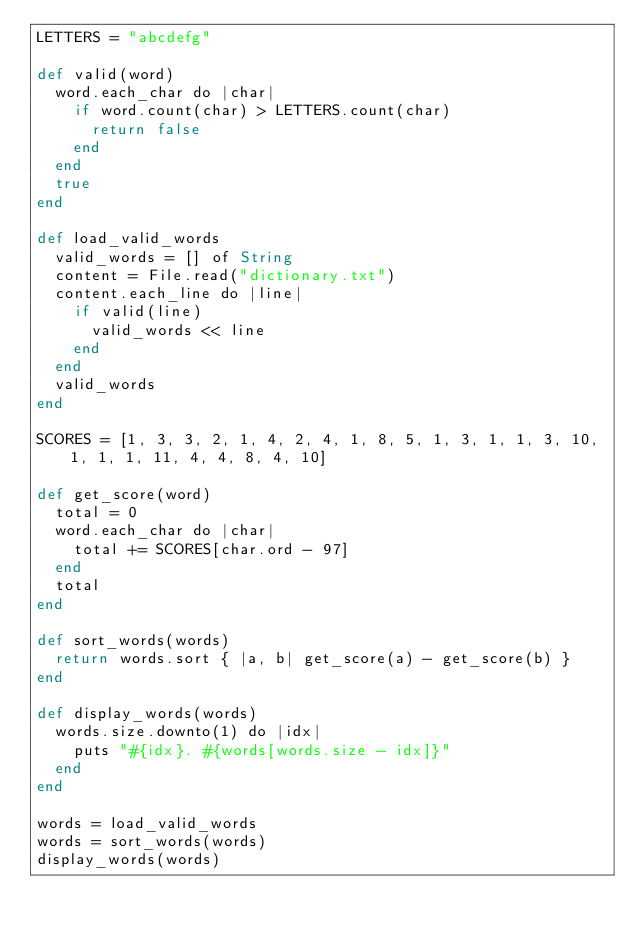<code> <loc_0><loc_0><loc_500><loc_500><_Crystal_>LETTERS = "abcdefg"

def valid(word)
  word.each_char do |char|
    if word.count(char) > LETTERS.count(char)
      return false
    end
  end
  true
end

def load_valid_words
  valid_words = [] of String
  content = File.read("dictionary.txt")
  content.each_line do |line|
    if valid(line)
      valid_words << line
    end
  end
  valid_words
end

SCORES = [1, 3, 3, 2, 1, 4, 2, 4, 1, 8, 5, 1, 3, 1, 1, 3, 10, 1, 1, 1, 11, 4, 4, 8, 4, 10]

def get_score(word)
  total = 0
  word.each_char do |char|
    total += SCORES[char.ord - 97]
  end
  total
end

def sort_words(words)
  return words.sort { |a, b| get_score(a) - get_score(b) }
end

def display_words(words)
  words.size.downto(1) do |idx|
    puts "#{idx}. #{words[words.size - idx]}"
  end
end

words = load_valid_words
words = sort_words(words)
display_words(words)</code> 